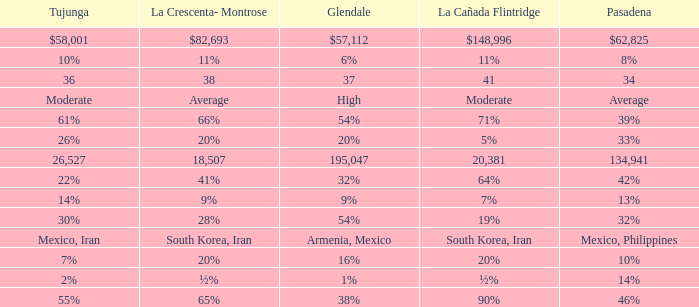When Tujunga is moderate, what is La Crescenta-Montrose? Average. 